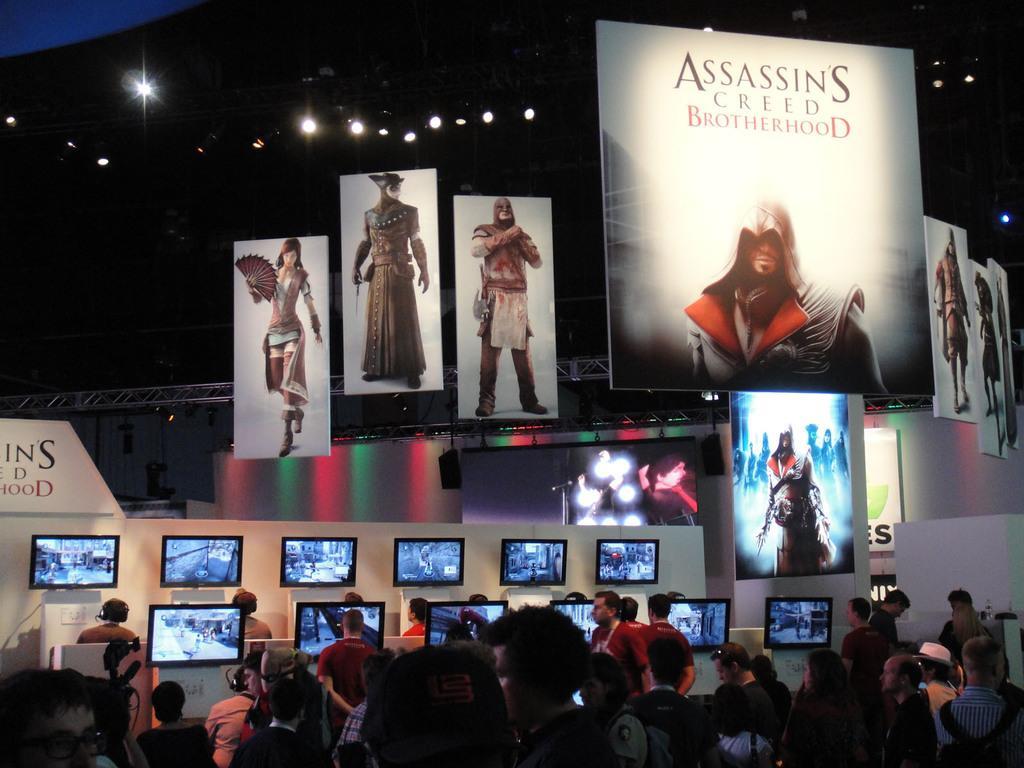Could you give a brief overview of what you see in this image? In this image there are a few people standing and watching televisions in front of them, at the top of the image there are posters and screens with lights. 